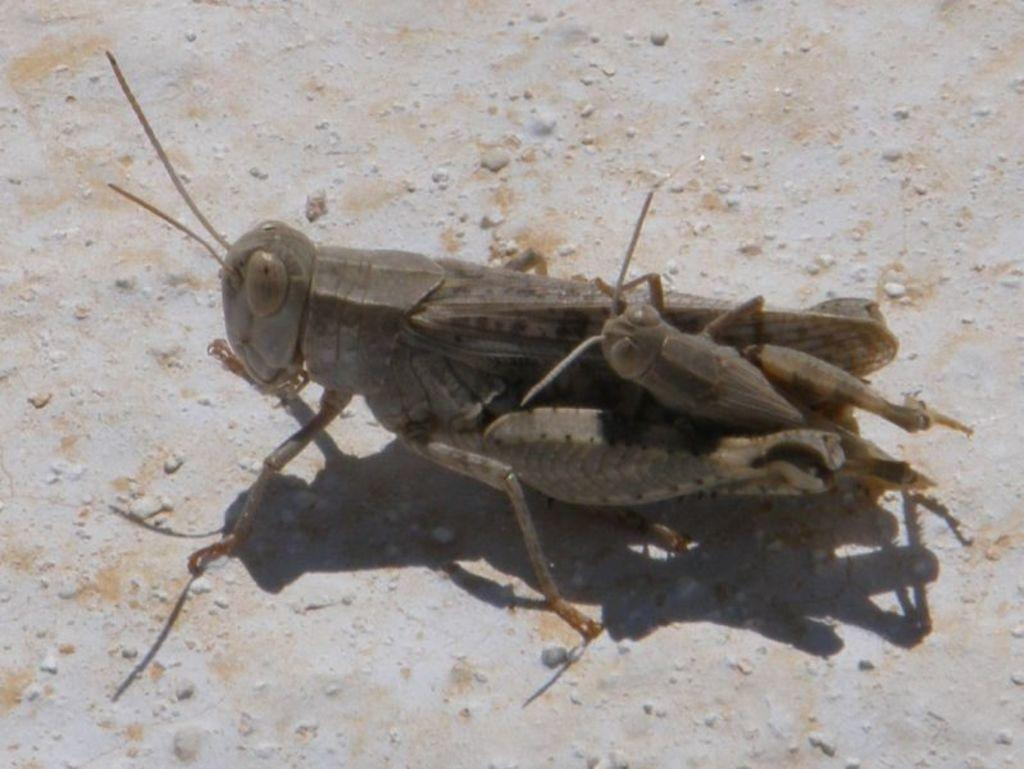What type of creatures can be seen on the surface in the image? There are insects on the surface in the image. How many trees can be seen in the image? There are no trees present in the image; it only shows insects on a surface. Can you describe the insects' biting behavior in the image? The image does not show the insects' behavior, including biting, so it cannot be described. 